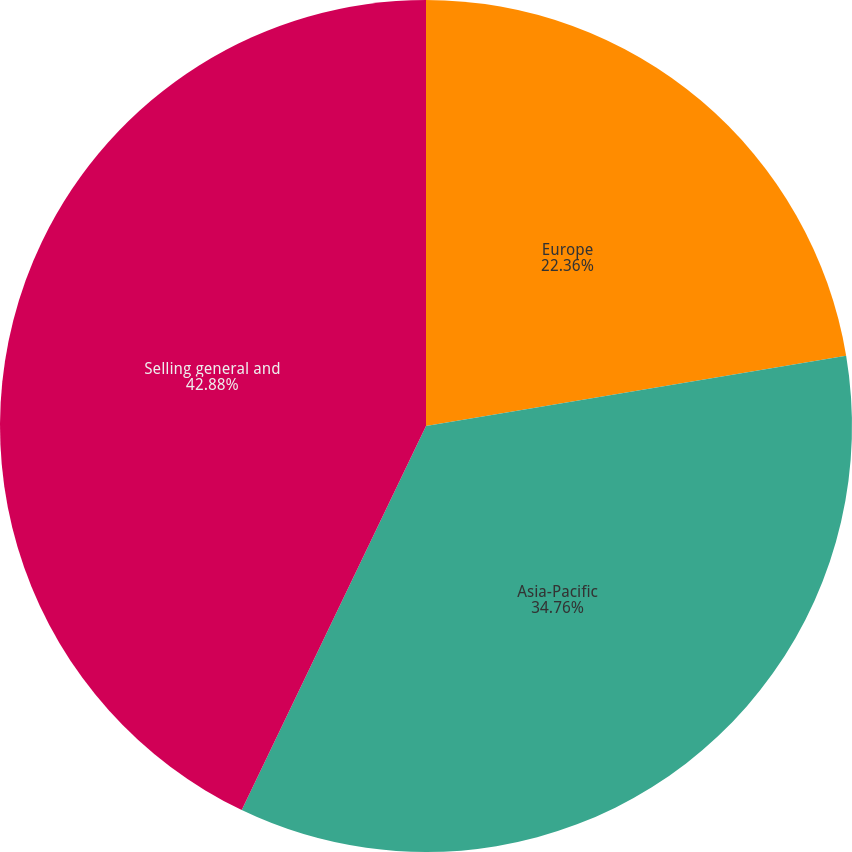Convert chart. <chart><loc_0><loc_0><loc_500><loc_500><pie_chart><fcel>Europe<fcel>Asia-Pacific<fcel>Selling general and<nl><fcel>22.36%<fcel>34.76%<fcel>42.88%<nl></chart> 